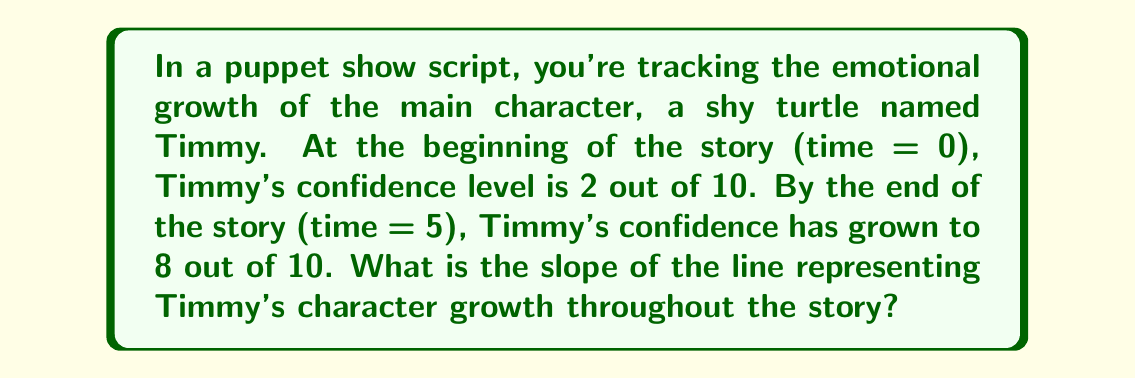Give your solution to this math problem. Let's approach this step-by-step:

1) The slope of a line is calculated using the formula:

   $$ m = \frac{y_2 - y_1}{x_2 - x_1} $$

   Where $(x_1, y_1)$ is the initial point and $(x_2, y_2)$ is the final point.

2) In this case:
   - $x_1 = 0$ (beginning of the story)
   - $y_1 = 2$ (initial confidence level)
   - $x_2 = 5$ (end of the story)
   - $y_2 = 8$ (final confidence level)

3) Let's plug these values into the slope formula:

   $$ m = \frac{8 - 2}{5 - 0} = \frac{6}{5} $$

4) Simplify:
   
   $$ m = \frac{6}{5} = 1.2 $$

This slope indicates that Timmy's confidence increases by 1.2 units for each unit of time in the story.
Answer: $\frac{6}{5}$ or 1.2 